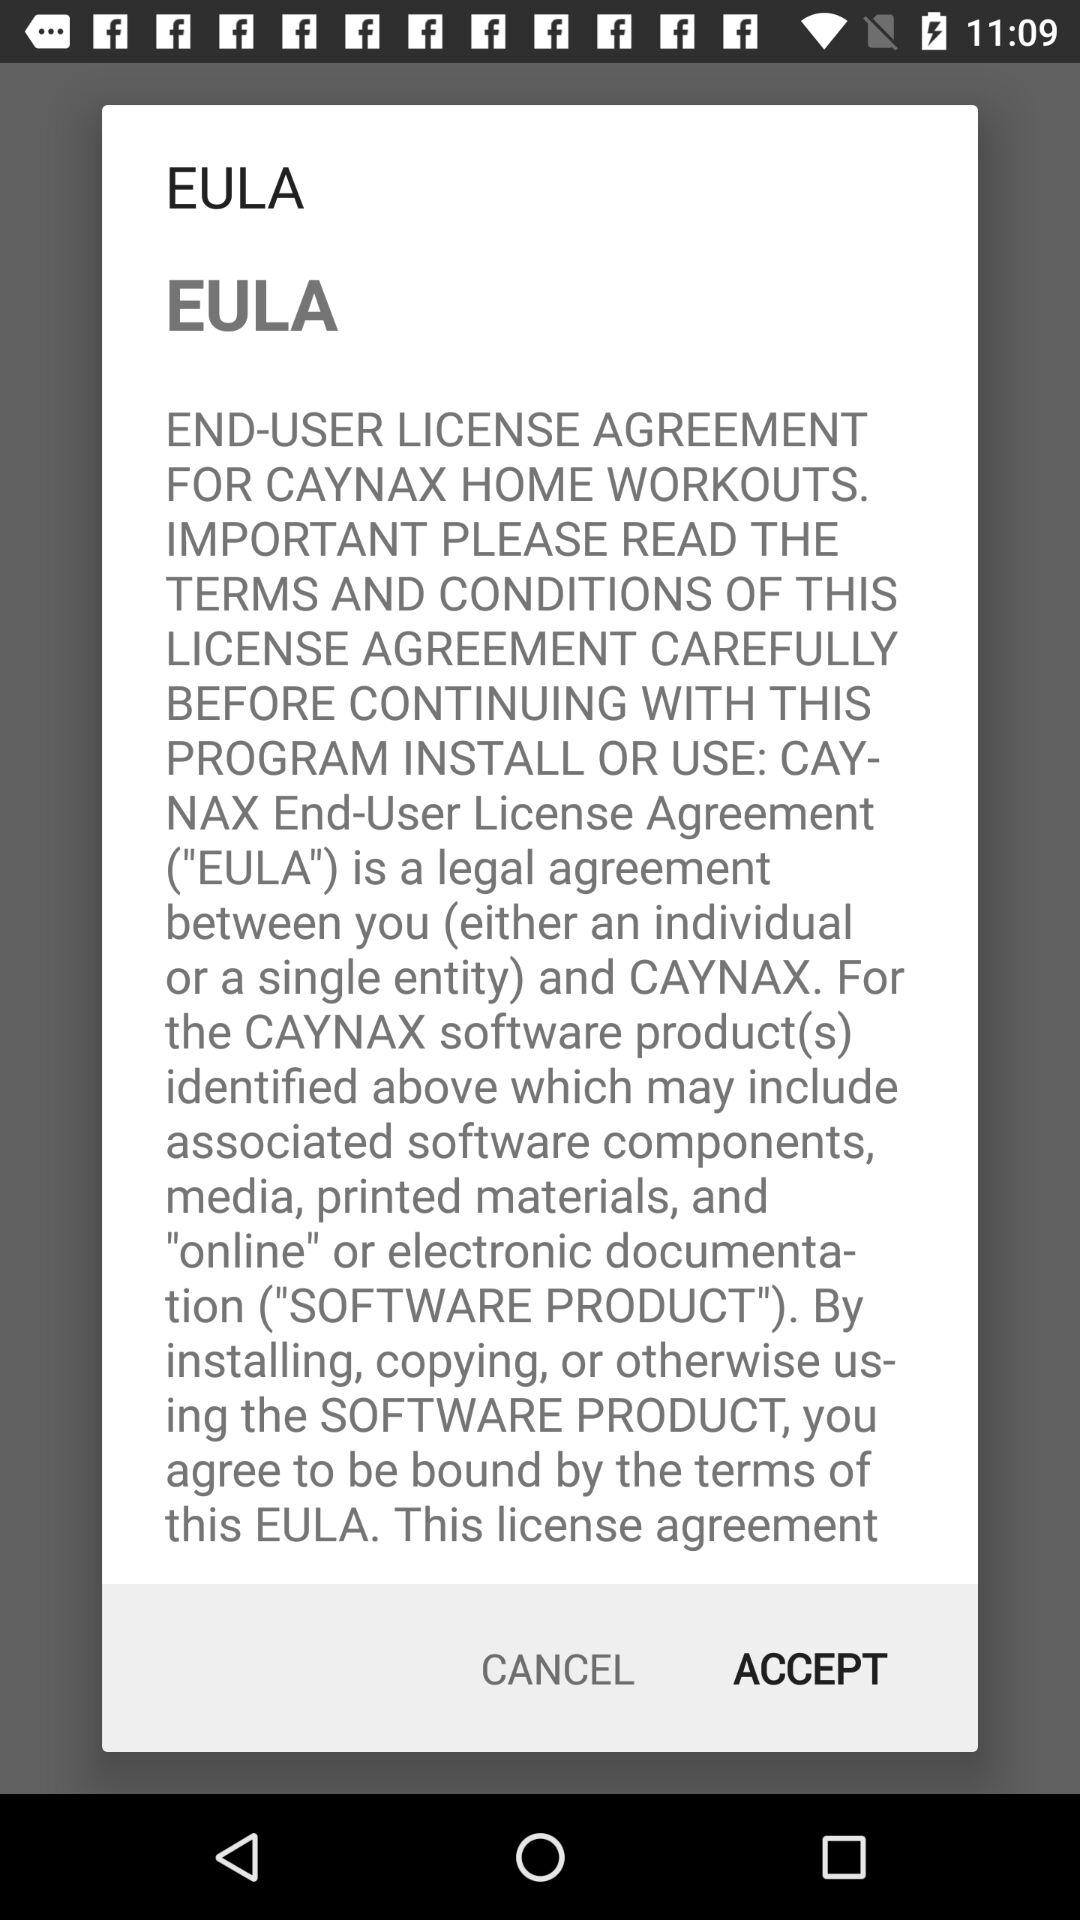What is the version number?
When the provided information is insufficient, respond with <no answer>. <no answer> 